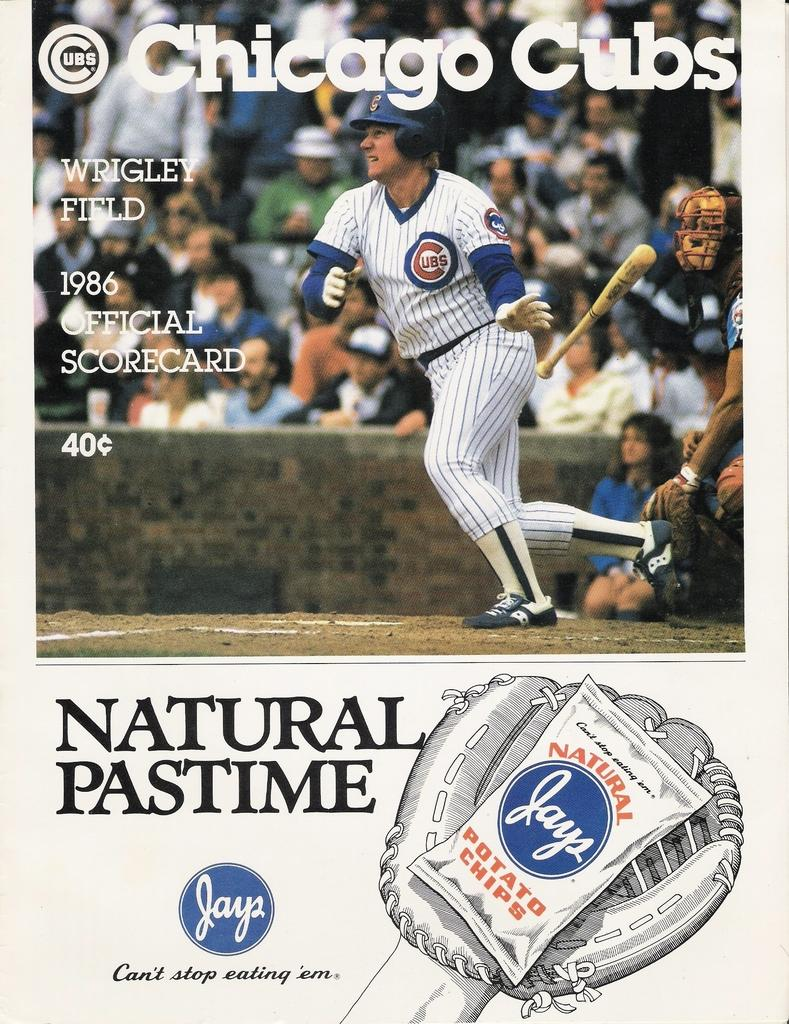<image>
Give a short and clear explanation of the subsequent image. A scorecard for the Cubs is sponsored by Jays potato chips. 